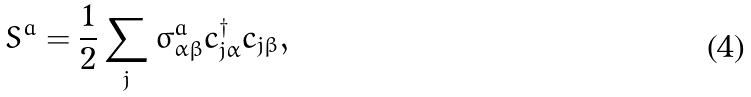Convert formula to latex. <formula><loc_0><loc_0><loc_500><loc_500>S ^ { a } = \frac { 1 } { 2 } \sum _ { j } \sigma _ { \alpha \beta } ^ { a } c _ { j \alpha } ^ { \dagger } c _ { j \beta } ,</formula> 